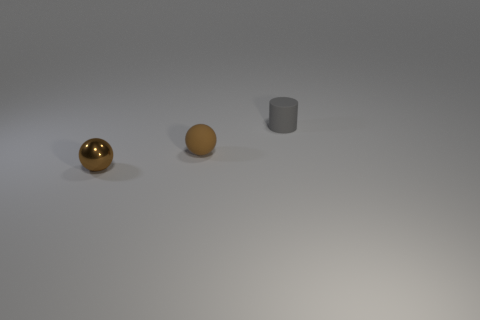Add 1 tiny gray rubber cylinders. How many objects exist? 4 Subtract all balls. How many objects are left? 1 Add 3 brown rubber objects. How many brown rubber objects exist? 4 Subtract 0 brown cylinders. How many objects are left? 3 Subtract all spheres. Subtract all small cylinders. How many objects are left? 0 Add 3 gray cylinders. How many gray cylinders are left? 4 